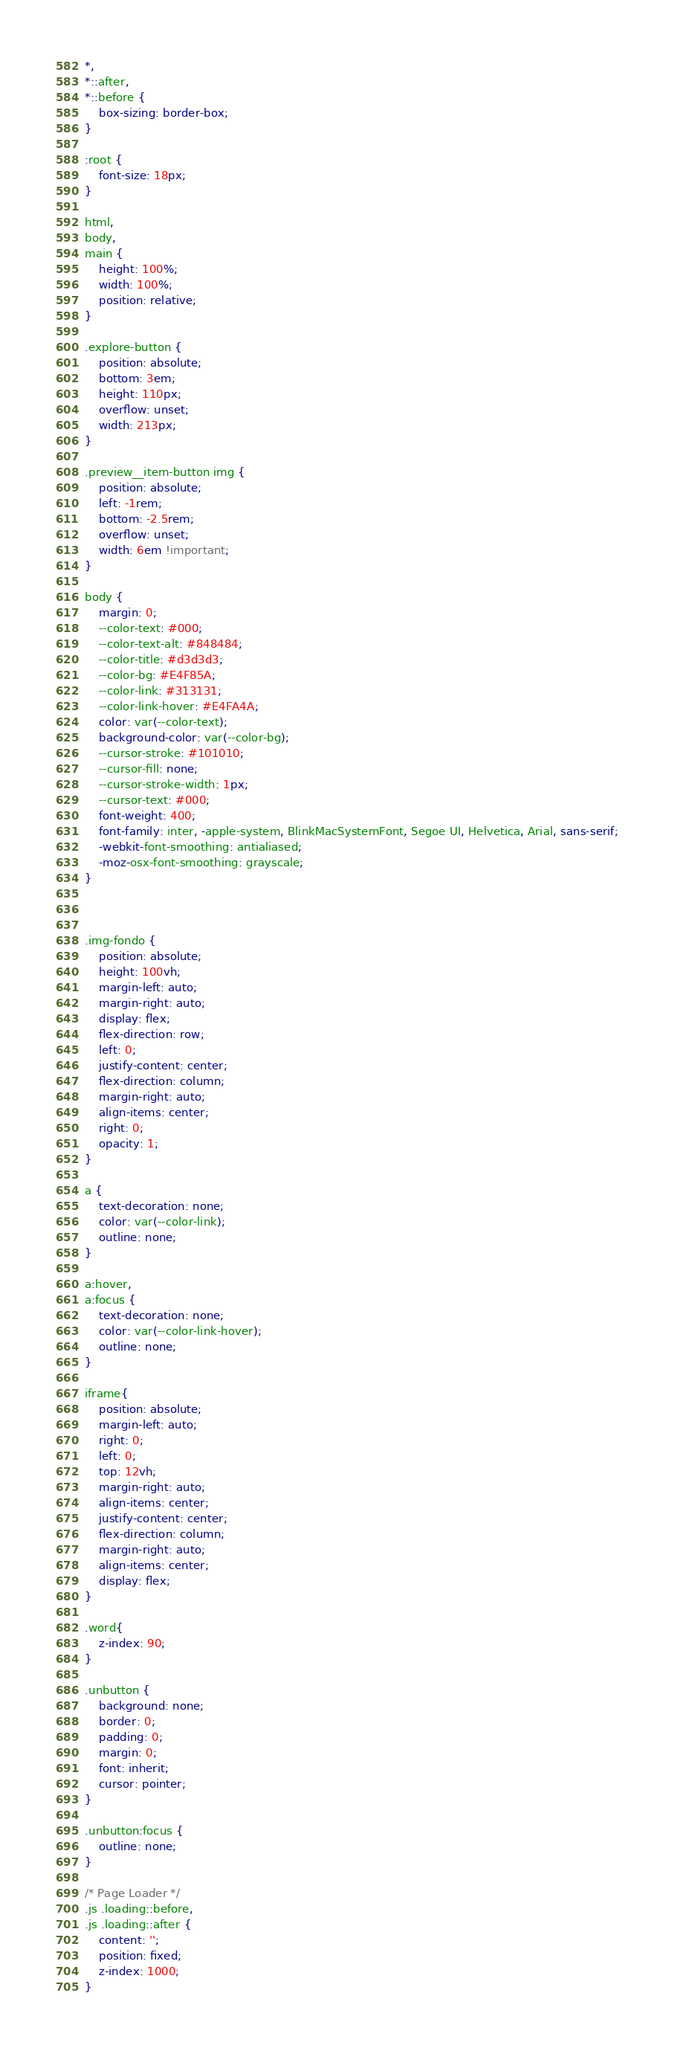Convert code to text. <code><loc_0><loc_0><loc_500><loc_500><_CSS_>*,
*::after,
*::before {
	box-sizing: border-box;
}

:root {
	font-size: 18px;
}

html, 
body, 
main {
	height: 100%;
	width: 100%;
	position: relative;
}

.explore-button {
    position: absolute;
    bottom: 3em;
    height: 110px;
    overflow: unset;
    width: 213px;
}

.preview__item-button img {
    position: absolute;
    left: -1rem;
    bottom: -2.5rem;
    overflow: unset;
    width: 6em !important;
}

body {
	margin: 0;
	--color-text: #000;
	--color-text-alt: #848484;
	--color-title: #d3d3d3;
    --color-bg: #E4F85A;
    --color-link: #313131;
	--color-link-hover: #E4FA4A;
    color: var(--color-text);
    background-color: var(--color-bg);
    --cursor-stroke: #101010;
    --cursor-fill: none;
    --cursor-stroke-width: 1px;
    --cursor-text: #000;
    font-weight: 400;
	font-family: inter, -apple-system, BlinkMacSystemFont, Segoe UI, Helvetica, Arial, sans-serif;
	-webkit-font-smoothing: antialiased;
	-moz-osx-font-smoothing: grayscale;
}



.img-fondo {
 	position: absolute;
    height: 100vh;
    margin-left: auto;
    margin-right: auto;
    display: flex;
    flex-direction: row;
    left: 0;
    justify-content: center;
    flex-direction: column;
    margin-right: auto;
    align-items: center;
    right: 0;
    opacity: 1;
}

a {
	text-decoration: none;
	color: var(--color-link);
	outline: none;
}

a:hover,
a:focus {
	text-decoration: none;
	color: var(--color-link-hover);
	outline: none;
}

iframe{
	position: absolute;
    margin-left: auto;
    right: 0;
    left: 0;
    top: 12vh;
    margin-right: auto;
    align-items: center;
    justify-content: center;
    flex-direction: column;
    margin-right: auto;
    align-items: center;
    display: flex;
}

.word{
	z-index: 90;
}

.unbutton {
	background: none;
	border: 0;
	padding: 0;
	margin: 0;
	font: inherit;
	cursor: pointer;
}

.unbutton:focus {
	outline: none;
}

/* Page Loader */
.js .loading::before,
.js .loading::after {
	content: '';
	position: fixed;
	z-index: 1000;
}
</code> 